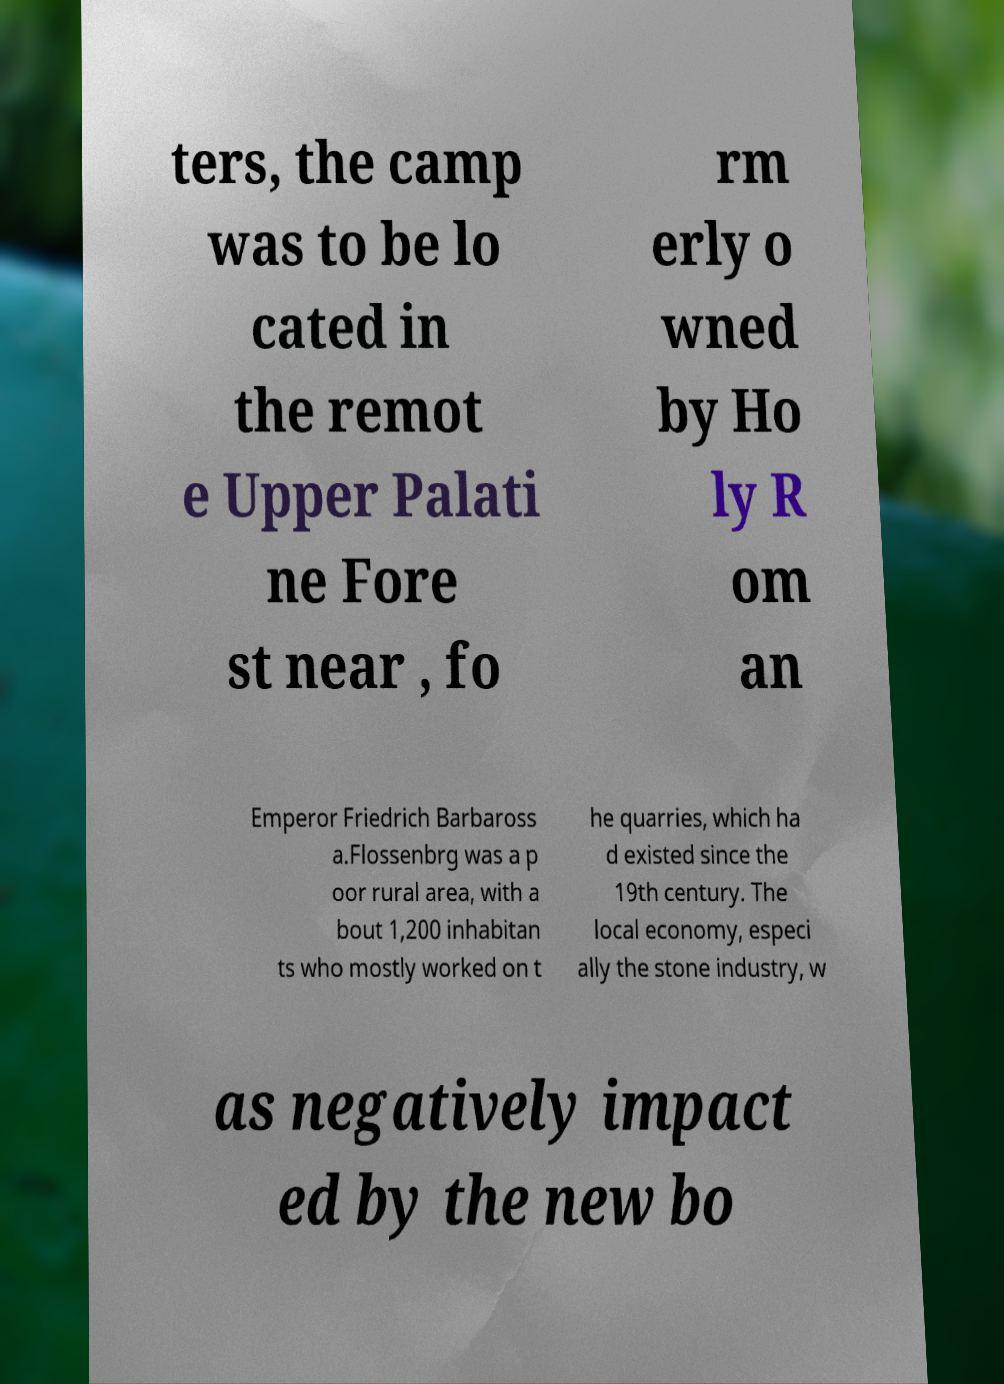Please identify and transcribe the text found in this image. ters, the camp was to be lo cated in the remot e Upper Palati ne Fore st near , fo rm erly o wned by Ho ly R om an Emperor Friedrich Barbaross a.Flossenbrg was a p oor rural area, with a bout 1,200 inhabitan ts who mostly worked on t he quarries, which ha d existed since the 19th century. The local economy, especi ally the stone industry, w as negatively impact ed by the new bo 